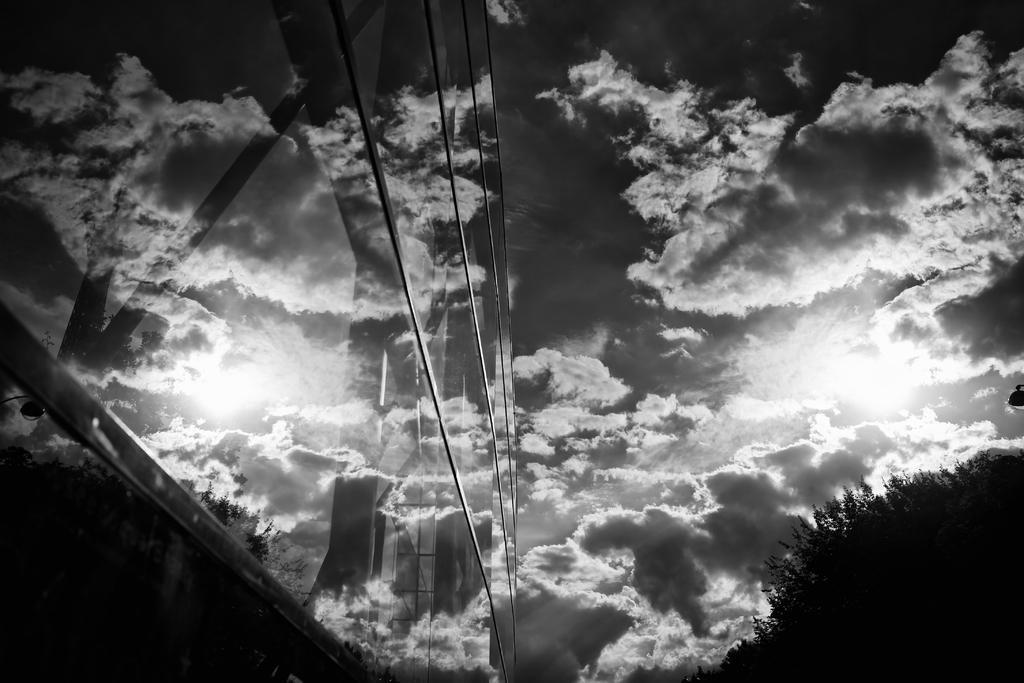Describe this image in one or two sentences. It is a black and white image. In this image, we can see the cloudy sky and glass building. On the glasses, we can see reflections. Through the glass objects, we can see pillars and rods. On the right side bottom corner, we can see trees. 